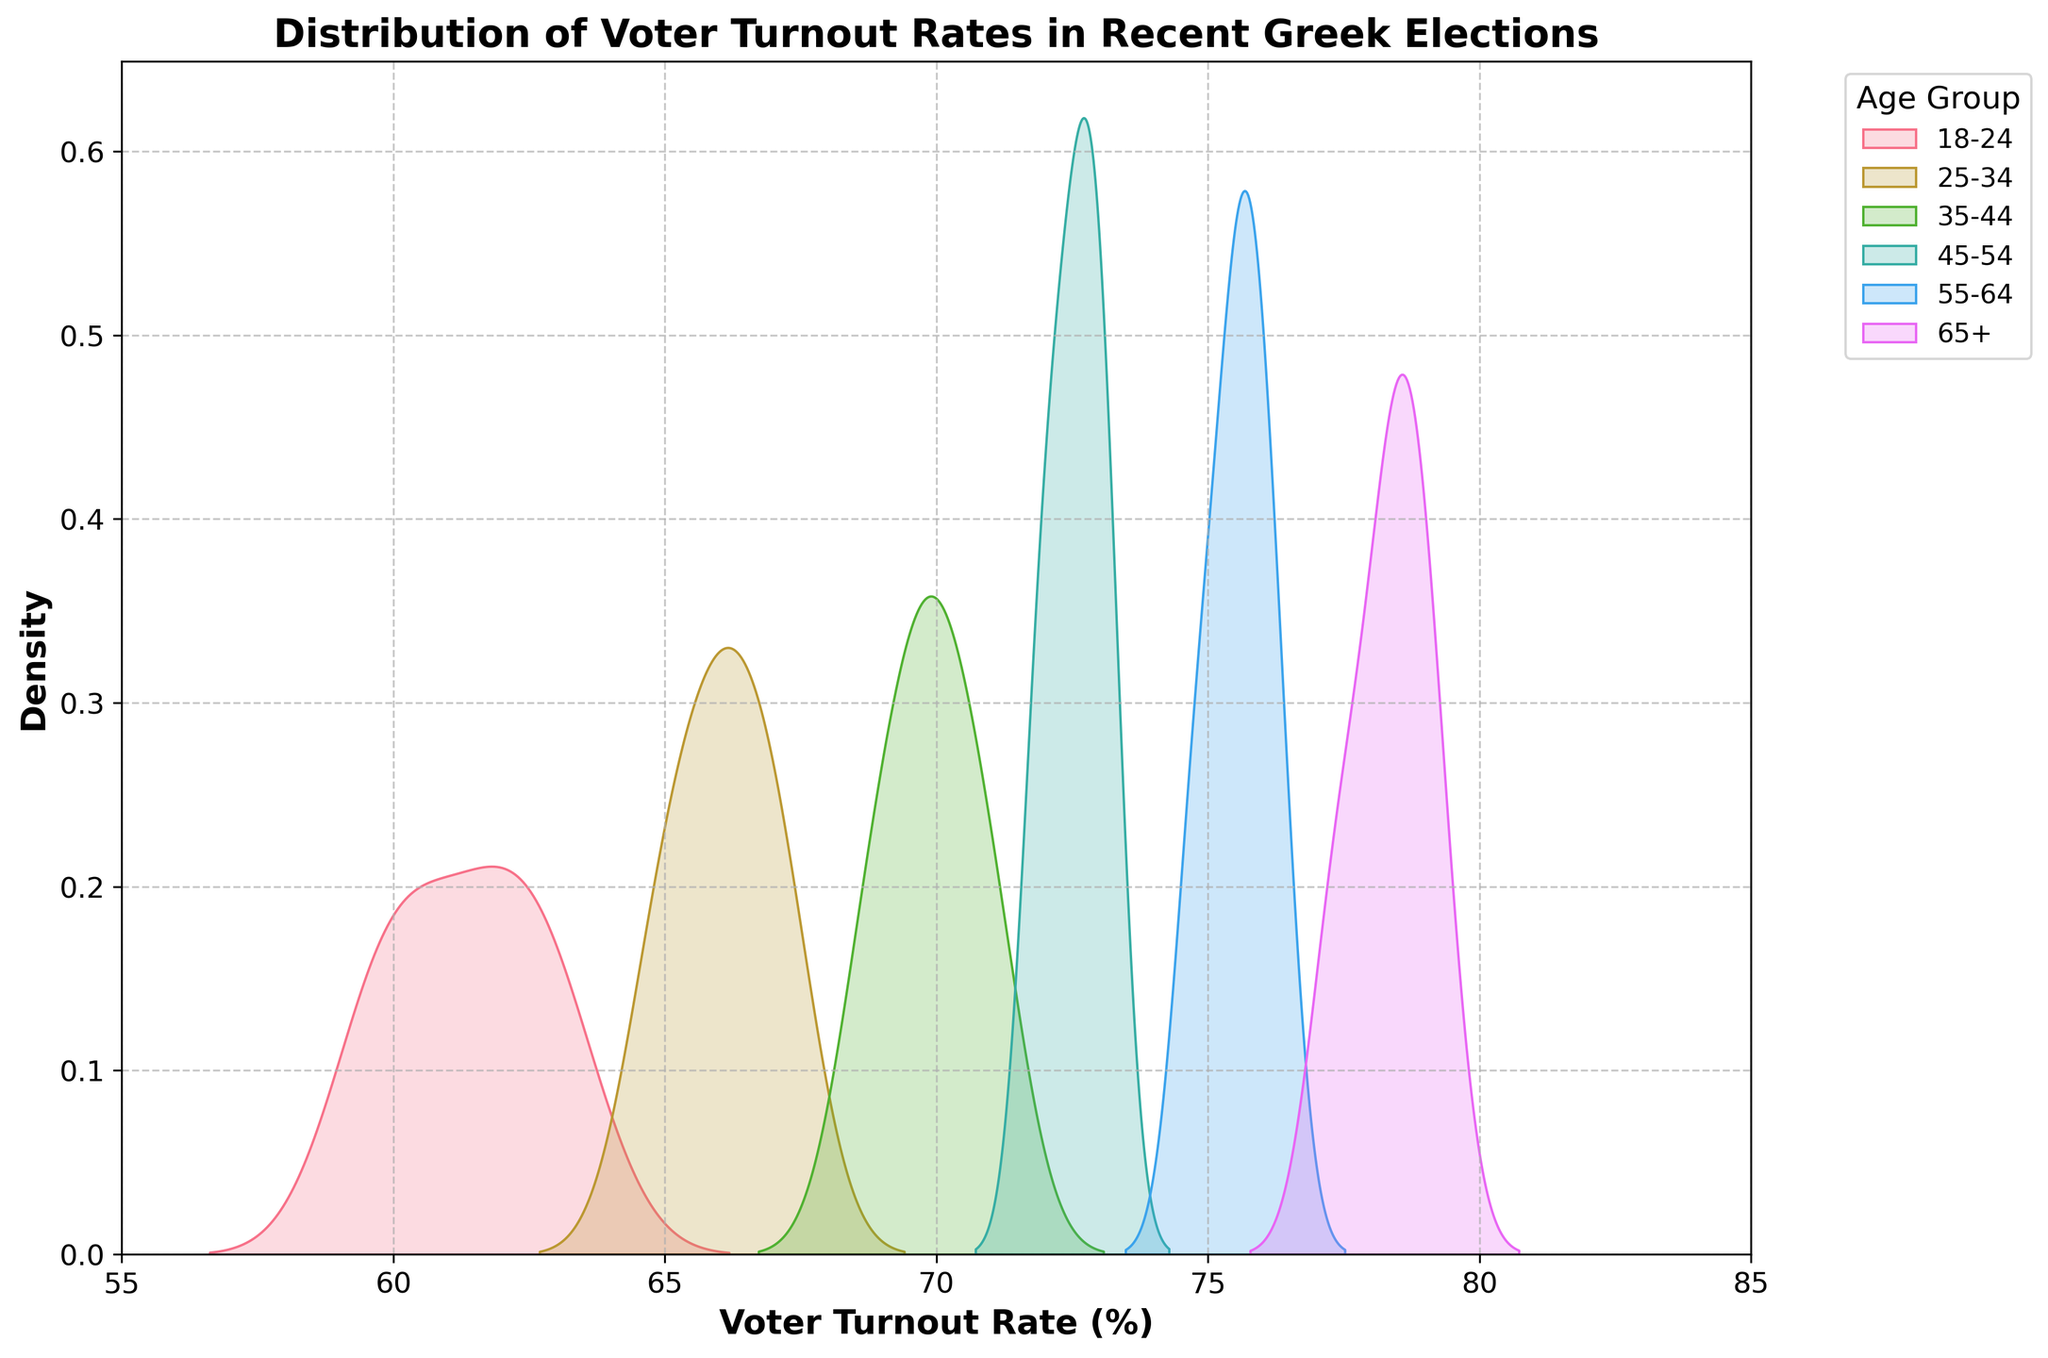What is the title of the plot? The title can be found at the top of the figure, and it mentions the topic displayed in the figure: "Distribution of Voter Turnout Rates in Recent Greek Elections".
Answer: Distribution of Voter Turnout Rates in Recent Greek Elections What does the x-axis represent? The label of the x-axis indicates the variable it represents, which is "Voter Turnout Rate (%)".
Answer: Voter Turnout Rate (%) Which age group shows the highest density peak in turnout rates? By looking at the peaks of the density curves for each age group, the curve for the 65+ age group clearly has the highest peak, indicating the highest density in this group.
Answer: 65+ How do the voter turnout rates compare between the 18-24 age group and the 65+ age group? By comparing the density curves for both age groups, the 65+ age group has higher voter turnout rates, as their density curve is more towards the right side of the plot, indicating higher percentages.
Answer: 65+ age group has higher rates Which age group has the narrowest distribution of turnout rates? The narrowest distribution can be observed from the width of the density curve; the 18-24 age group's curve appears to be the widest, whereas the 65+ age group has a relatively narrower curve.
Answer: 65+ age group What is the range of the x-axis? The limits of the x-axis can be seen at the bottom of the plot, starting at 55% and ending at 85%.
Answer: 55% to 85% Which age group has turnout rates predominantly around 70%? By looking at the density curves, the 35-44 age group shows its peak around the 70% mark, indicating most of its turnout rates are around this value.
Answer: 35-44 age group Describe the overall trend in voter turnout rates as age increases. Assessing the density peaks from left to right on the plot, an increasing trend is noticed where older age groups tend to have higher voter turnout rates.
Answer: Increasing trend with age Is there a significant overlap between the age groups in terms of turnout rates? Observing the density curves, there is some overlap, particularly between adjacent age groups like 55-64 and 65+, indicating some similar turnout rates among these groups.
Answer: Yes, there is some overlap Which age group shows the lowest voter turnout rates? Examining the density curves, the 18-24 age group has its peak and distribution towards the lower end of the x-axis, showing the lowest voter turnout rates.
Answer: 18-24 age group 